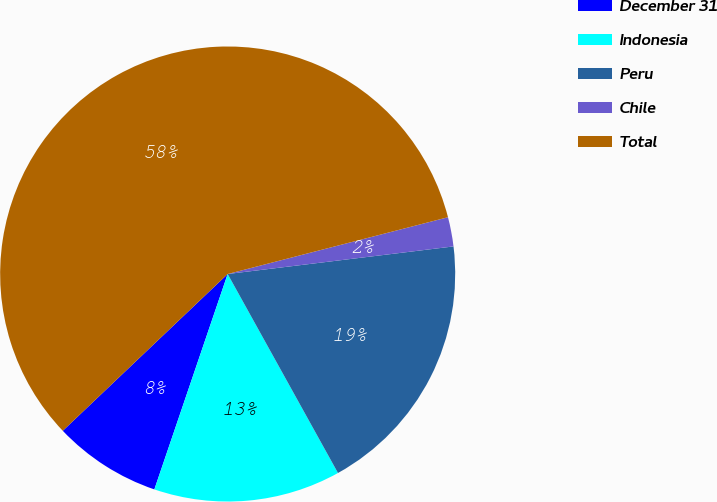Convert chart. <chart><loc_0><loc_0><loc_500><loc_500><pie_chart><fcel>December 31<fcel>Indonesia<fcel>Peru<fcel>Chile<fcel>Total<nl><fcel>7.68%<fcel>13.28%<fcel>18.88%<fcel>2.08%<fcel>58.09%<nl></chart> 